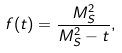<formula> <loc_0><loc_0><loc_500><loc_500>f ( t ) = \frac { M ^ { 2 } _ { S } } { M ^ { 2 } _ { S } - t } ,</formula> 